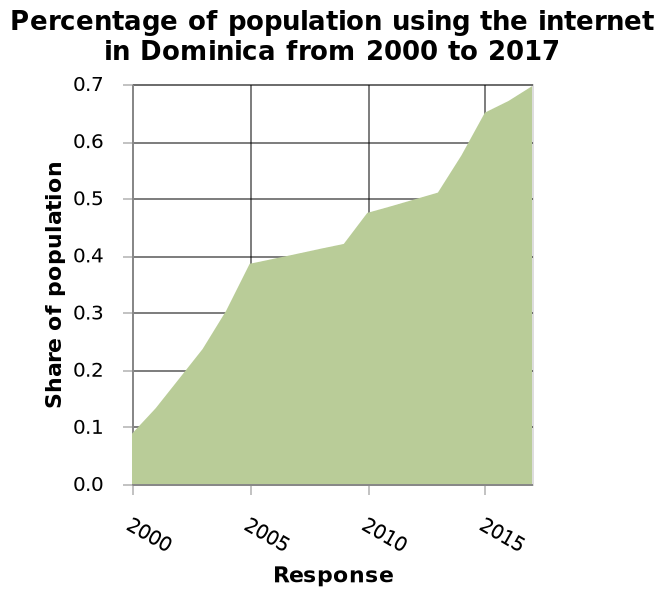<image>
please summary the statistics and relations of the chart The biggest and fastest increase in users of the internet was 2000 & 2005 and a steady but slow increase since. What is the range of values displayed on the y-axis? The range of values displayed on the y-axis is from 0.0 to 0.7. After 2005, did the number of internet users continue to increase? Yes, the number of internet users has continued to increase since 2005, albeit at a slower pace. 